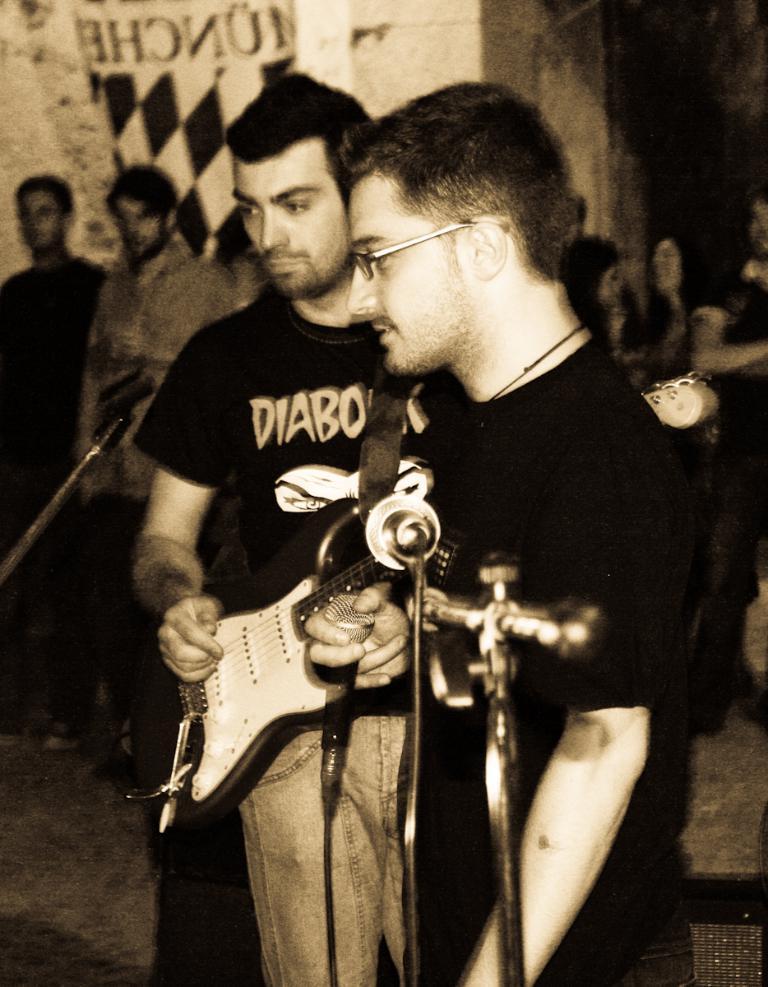Please provide a concise description of this image. In this picture there is a man who is playing a guitar. There is also another a man who is standing. There are group of people standing at the background. 